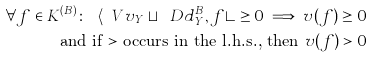Convert formula to latex. <formula><loc_0><loc_0><loc_500><loc_500>\forall f \in K ^ { ( B ) } \colon \ \langle \ V v _ { Y } \sqcup \ D d ^ { B } _ { Y } , f \rangle \geq 0 \implies v ( f ) \geq 0 \\ \text {and if $>$ occurs in the l.h.s., then $v(f)>0$}</formula> 